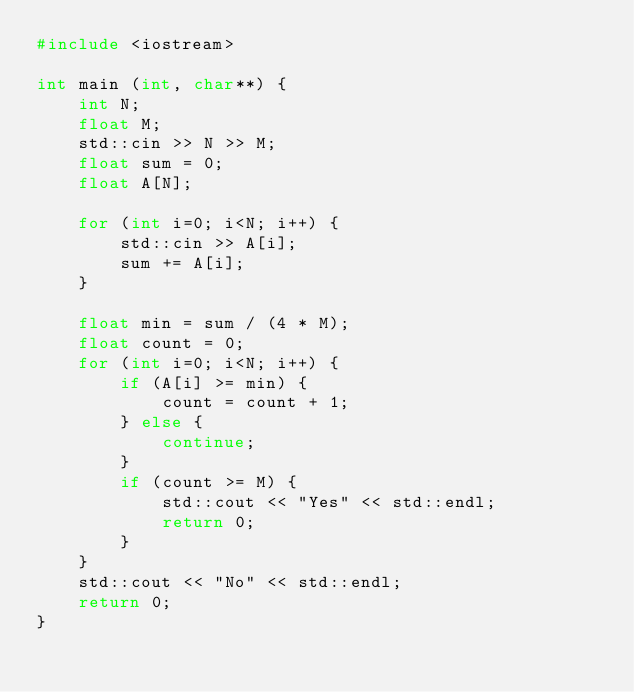Convert code to text. <code><loc_0><loc_0><loc_500><loc_500><_C++_>#include <iostream>

int main (int, char**) {
    int N;
    float M;
  	std::cin >> N >> M;
    float sum = 0;
    float A[N];

    for (int i=0; i<N; i++) {
        std::cin >> A[i];
        sum += A[i];
    }

    float min = sum / (4 * M);
    float count = 0;
    for (int i=0; i<N; i++) {
        if (A[i] >= min) {
            count = count + 1;
        } else {
            continue;
        }
        if (count >= M) {
            std::cout << "Yes" << std::endl;
            return 0;
        }
    }
    std::cout << "No" << std::endl;
    return 0;
}</code> 